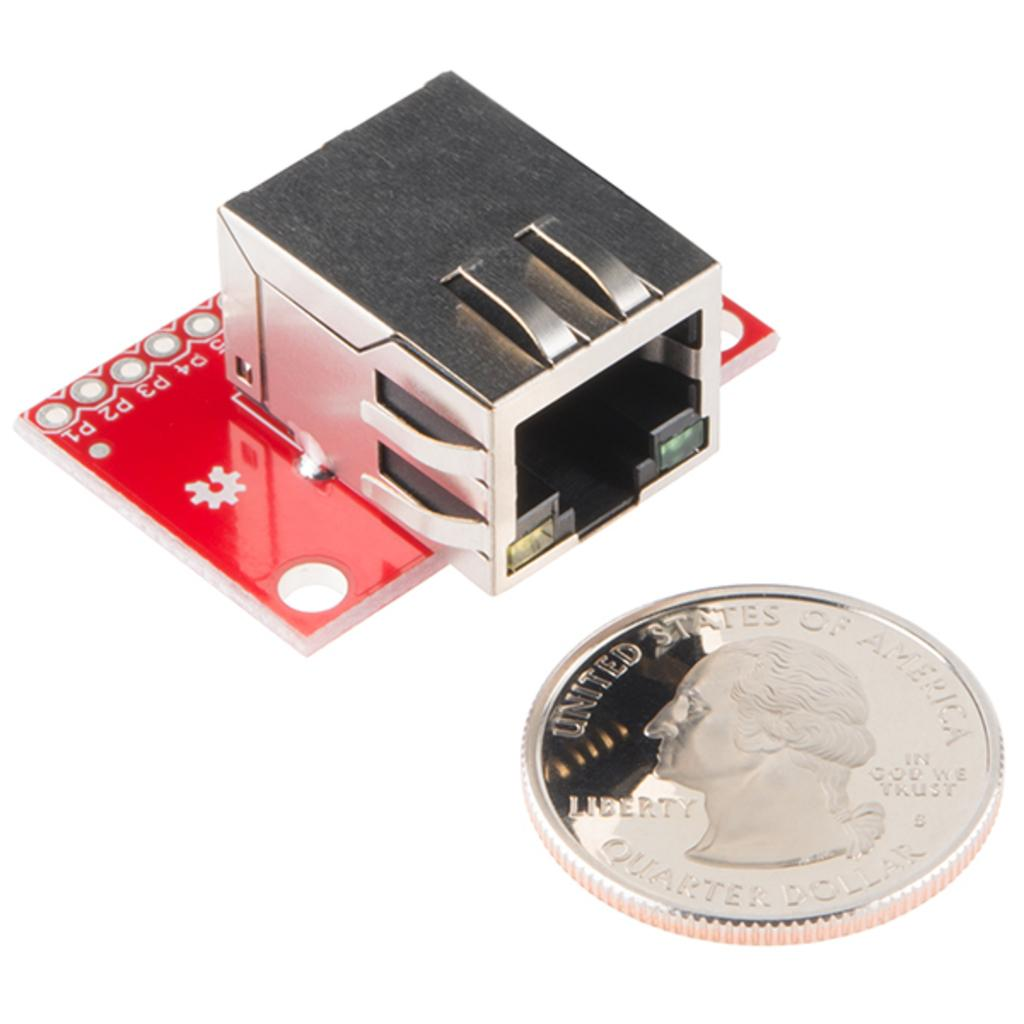<image>
Present a compact description of the photo's key features. a red and silver device with a united states of america quarter in front of it 